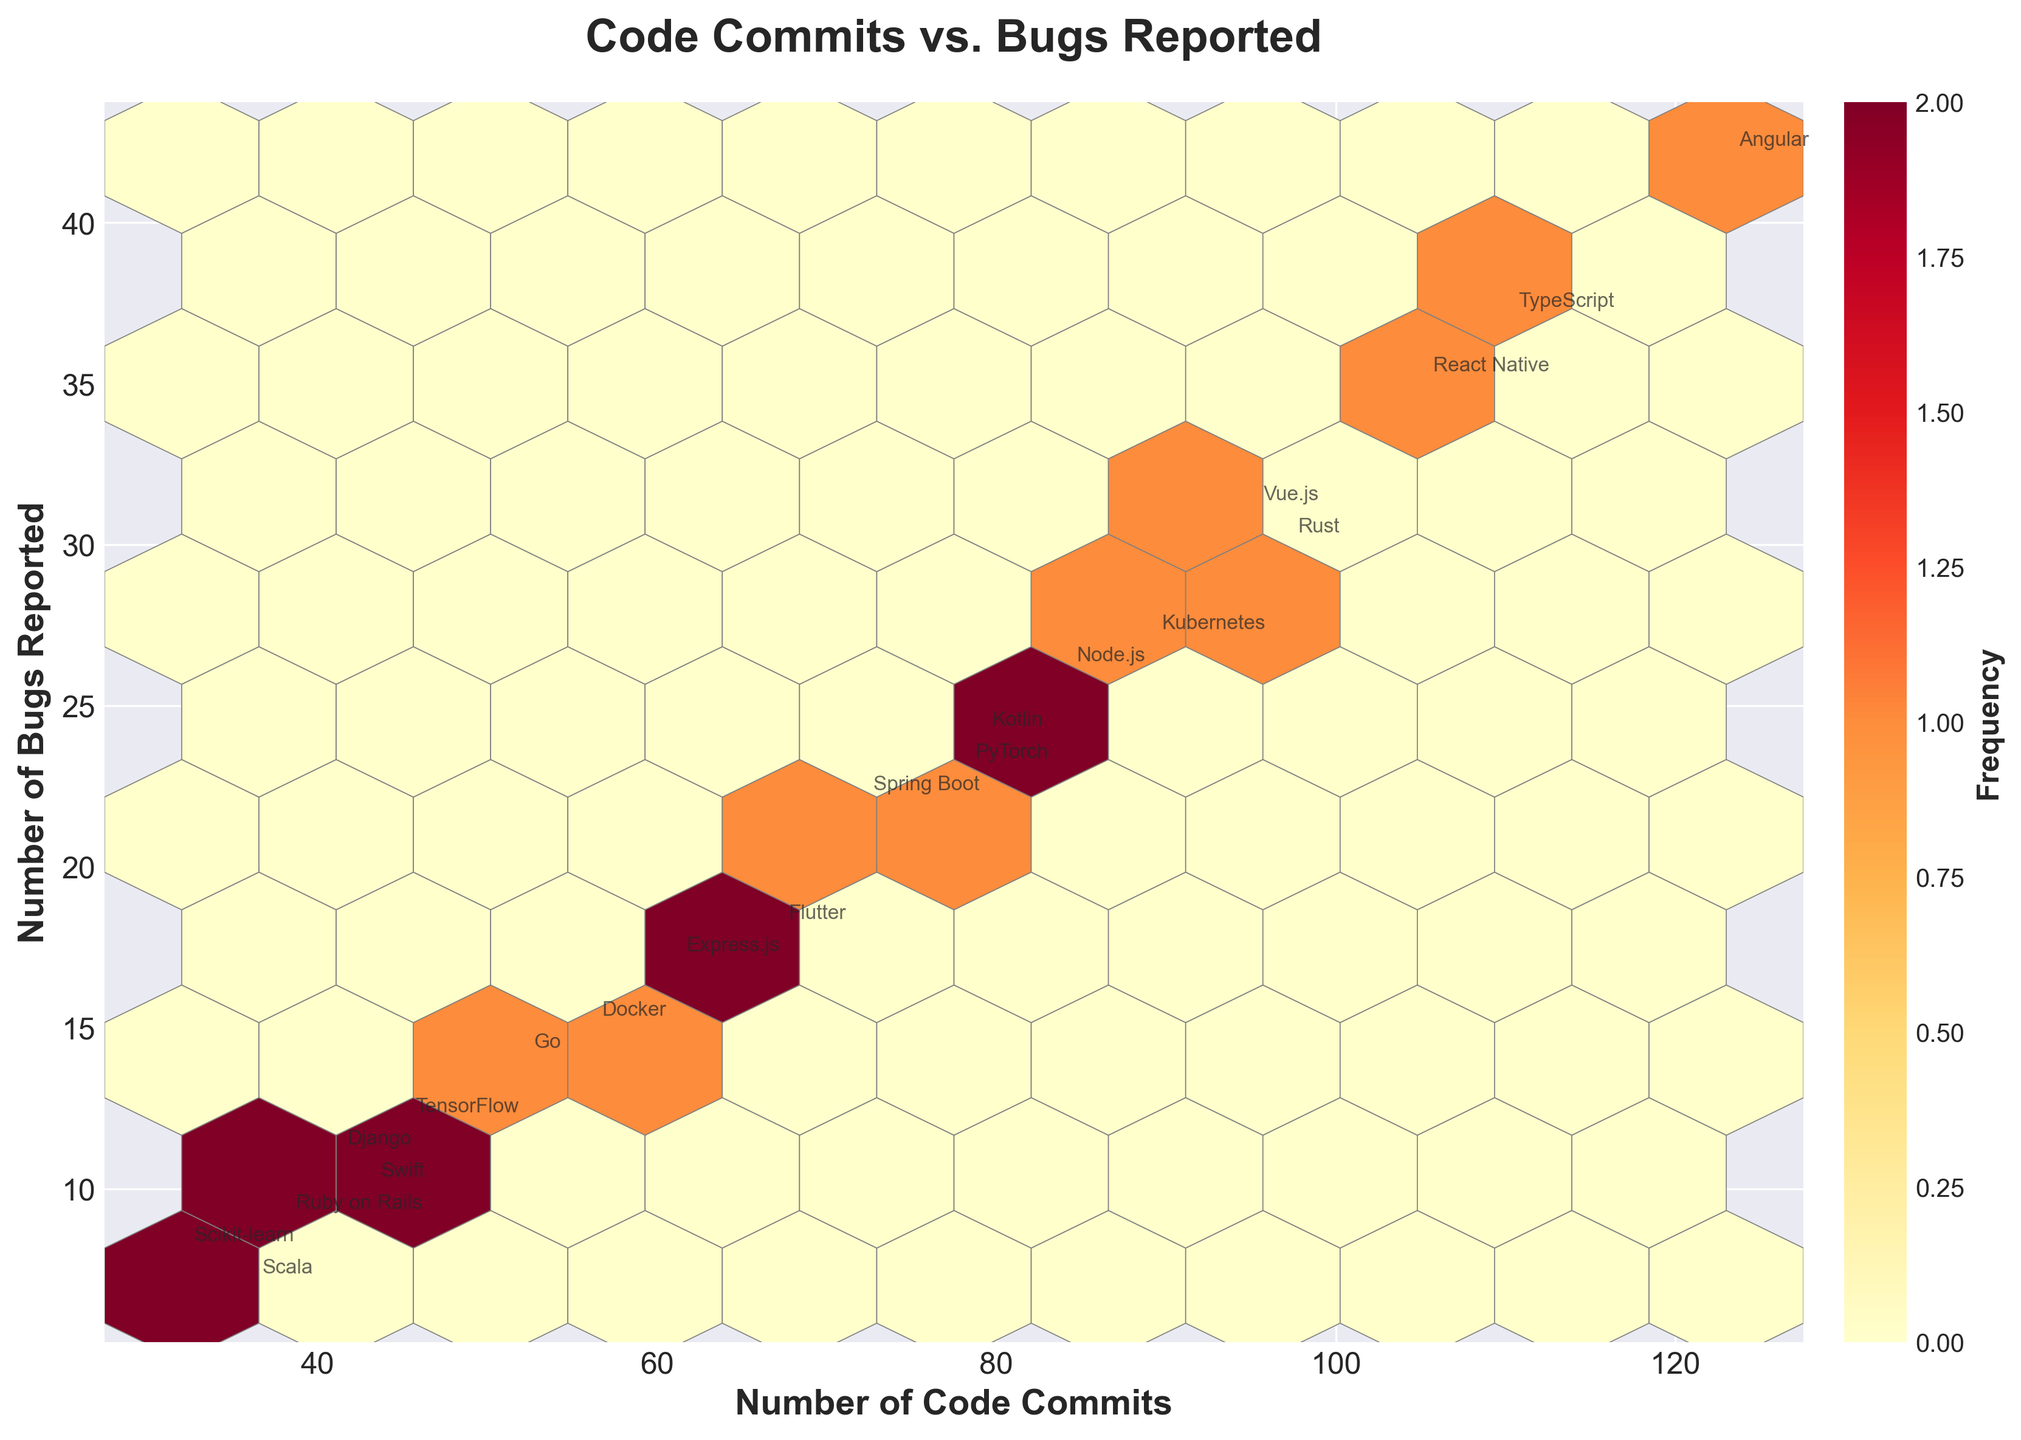How many projects have more than 90 code commits? To determine the number of projects with more than 90 code commits, look at the x-axis which represents the number of code commits and count the points annotated with the project names that lie to the right of the 90 code commits mark.
Answer: 6 What is the relationship between the number of code commits and the number of bugs reported? Observe the trend in the hexbin plot by looking at the concentration of the hexagons. Higher density and color intensity in a particular region indicate a stronger association. From the plot, regions with more code commits generally show a higher number of bugs reported.
Answer: Positive correlation Which project has the highest number of bugs reported? Identify the point that is located furthest up on the y-axis, which represents the number of bugs reported, and read the project name labeled nearby.
Answer: Angular What is the median number of code commits among the projects? Arrange the code commits data from smallest to largest and find the middle value. The sorted list is [32, 36, 38, 41, 43, 45, 52, 56, 61, 67, 72, 78, 79, 84, 89, 95, 97, 105, 110, 123], so the median is the average of the 10th and 11th values: (67 + 72)/2 = 69.5
Answer: 69.5 Compare the bug rates of projects with over 100 code commits to those with fewer. Which group tends to report more bugs on average? First, identify the projects with over 100 code commits (105, 110, 123) and calculate their average bugs: (35 + 37 + 42)/3 = 38. Then, do the same for the remaining projects: 
(12 + 23 + 8 + 18 + 27 + 15 + 31 + 11 + 22 + 9 + 26 + 17 + 14 + 30 + 10 + 24 + 7)/17 ≈ 17.65. Thus, projects with over 100 code commits average more bugs.
Answer: Projects with over 100 commits How does the frequency color bar help in interpreting the plot? The color bar to the right of the hexbin plot indicates the frequency of points in each hexagon, with darker shades representing higher frequencies. It helps in identifying clusters of similar data points.
Answer: Indicates frequency of points Which two projects have the most similar number of code commits and bugs reported? Look for pairs of points that are close together on the plot both horizontally and vertically, and check their labels. Based on the given data, "Django" and "TensorFlow" are close both in code commits and bugs reported.
Answer: Django and TensorFlow 